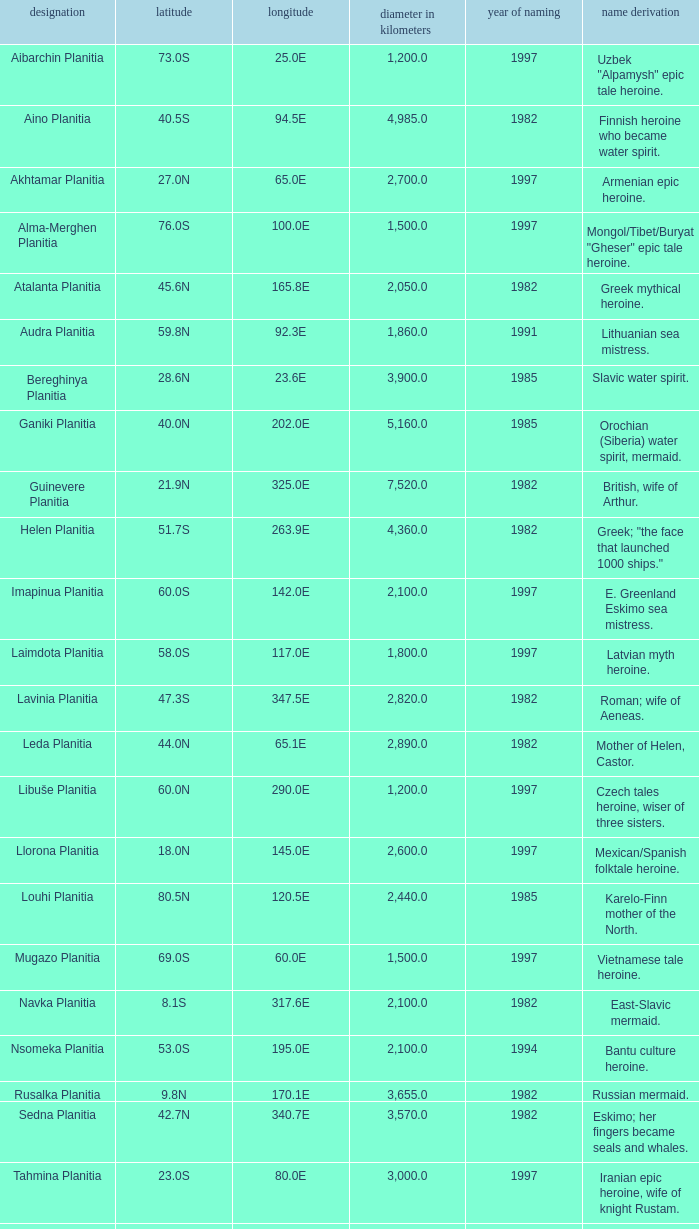What is the diameter (km) of the feature of latitude 23.0s 3000.0. 